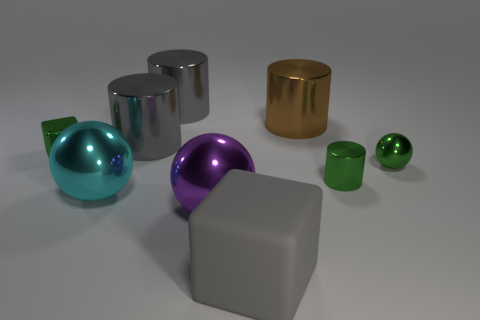Subtract 1 balls. How many balls are left? 2 Subtract all purple cylinders. Subtract all blue spheres. How many cylinders are left? 4 Add 1 large blue blocks. How many objects exist? 10 Subtract all blocks. How many objects are left? 7 Subtract all tiny cyan cylinders. Subtract all big gray cubes. How many objects are left? 8 Add 5 gray rubber blocks. How many gray rubber blocks are left? 6 Add 2 tiny yellow matte balls. How many tiny yellow matte balls exist? 2 Subtract 0 brown cubes. How many objects are left? 9 